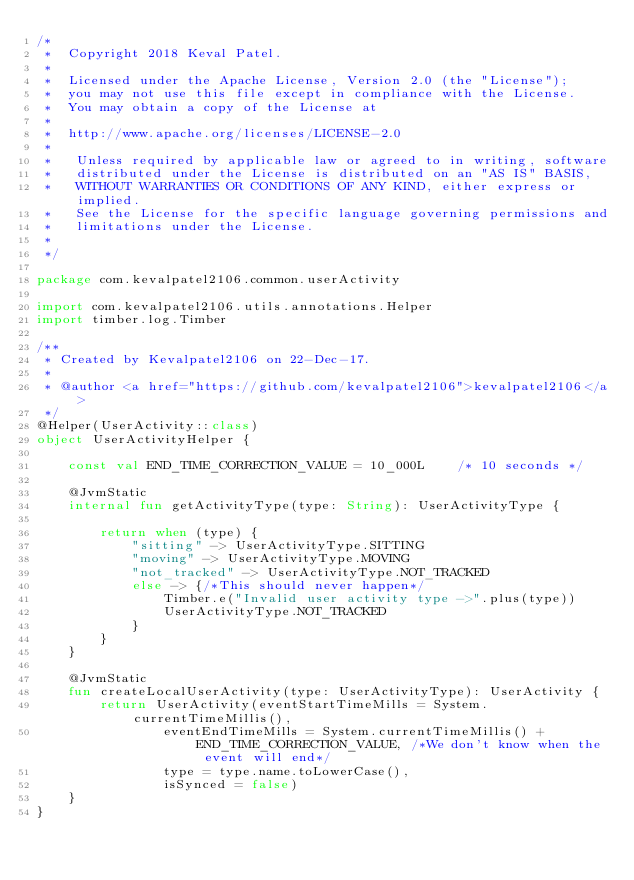Convert code to text. <code><loc_0><loc_0><loc_500><loc_500><_Kotlin_>/*
 *  Copyright 2018 Keval Patel.
 *
 *  Licensed under the Apache License, Version 2.0 (the "License");
 *  you may not use this file except in compliance with the License.
 *  You may obtain a copy of the License at
 *
 *  http://www.apache.org/licenses/LICENSE-2.0
 *
 *   Unless required by applicable law or agreed to in writing, software
 *   distributed under the License is distributed on an "AS IS" BASIS,
 *   WITHOUT WARRANTIES OR CONDITIONS OF ANY KIND, either express or implied.
 *   See the License for the specific language governing permissions and
 *   limitations under the License.
 *
 */

package com.kevalpatel2106.common.userActivity

import com.kevalpatel2106.utils.annotations.Helper
import timber.log.Timber

/**
 * Created by Kevalpatel2106 on 22-Dec-17.
 *
 * @author <a href="https://github.com/kevalpatel2106">kevalpatel2106</a>
 */
@Helper(UserActivity::class)
object UserActivityHelper {

    const val END_TIME_CORRECTION_VALUE = 10_000L    /* 10 seconds */

    @JvmStatic
    internal fun getActivityType(type: String): UserActivityType {

        return when (type) {
            "sitting" -> UserActivityType.SITTING
            "moving" -> UserActivityType.MOVING
            "not_tracked" -> UserActivityType.NOT_TRACKED
            else -> {/*This should never happen*/
                Timber.e("Invalid user activity type ->".plus(type))
                UserActivityType.NOT_TRACKED
            }
        }
    }

    @JvmStatic
    fun createLocalUserActivity(type: UserActivityType): UserActivity {
        return UserActivity(eventStartTimeMills = System.currentTimeMillis(),
                eventEndTimeMills = System.currentTimeMillis() + END_TIME_CORRECTION_VALUE, /*We don't know when the event will end*/
                type = type.name.toLowerCase(),
                isSynced = false)
    }
}
</code> 